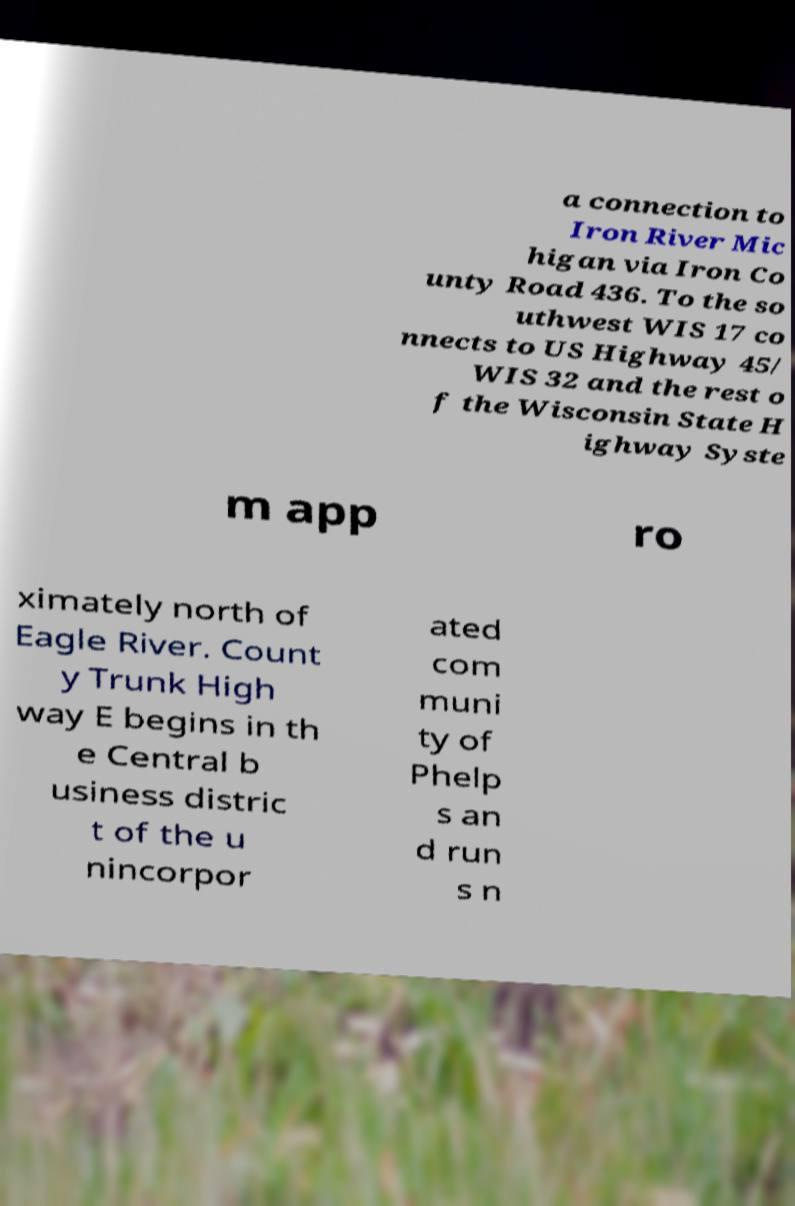There's text embedded in this image that I need extracted. Can you transcribe it verbatim? a connection to Iron River Mic higan via Iron Co unty Road 436. To the so uthwest WIS 17 co nnects to US Highway 45/ WIS 32 and the rest o f the Wisconsin State H ighway Syste m app ro ximately north of Eagle River. Count y Trunk High way E begins in th e Central b usiness distric t of the u nincorpor ated com muni ty of Phelp s an d run s n 